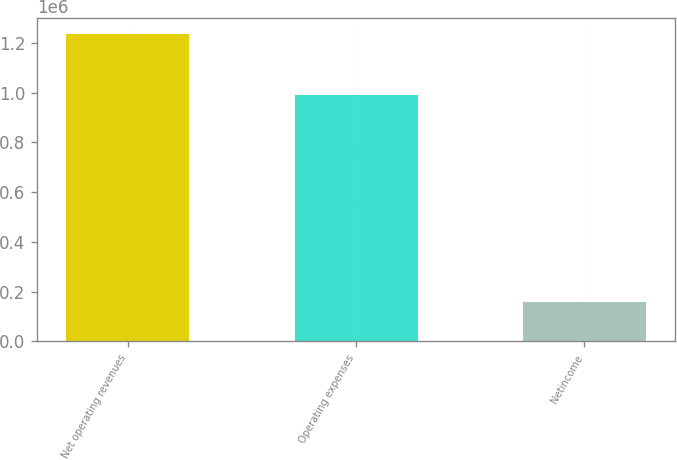Convert chart. <chart><loc_0><loc_0><loc_500><loc_500><bar_chart><fcel>Net operating revenues<fcel>Operating expenses<fcel>Netincome<nl><fcel>1.23641e+06<fcel>990504<fcel>157329<nl></chart> 